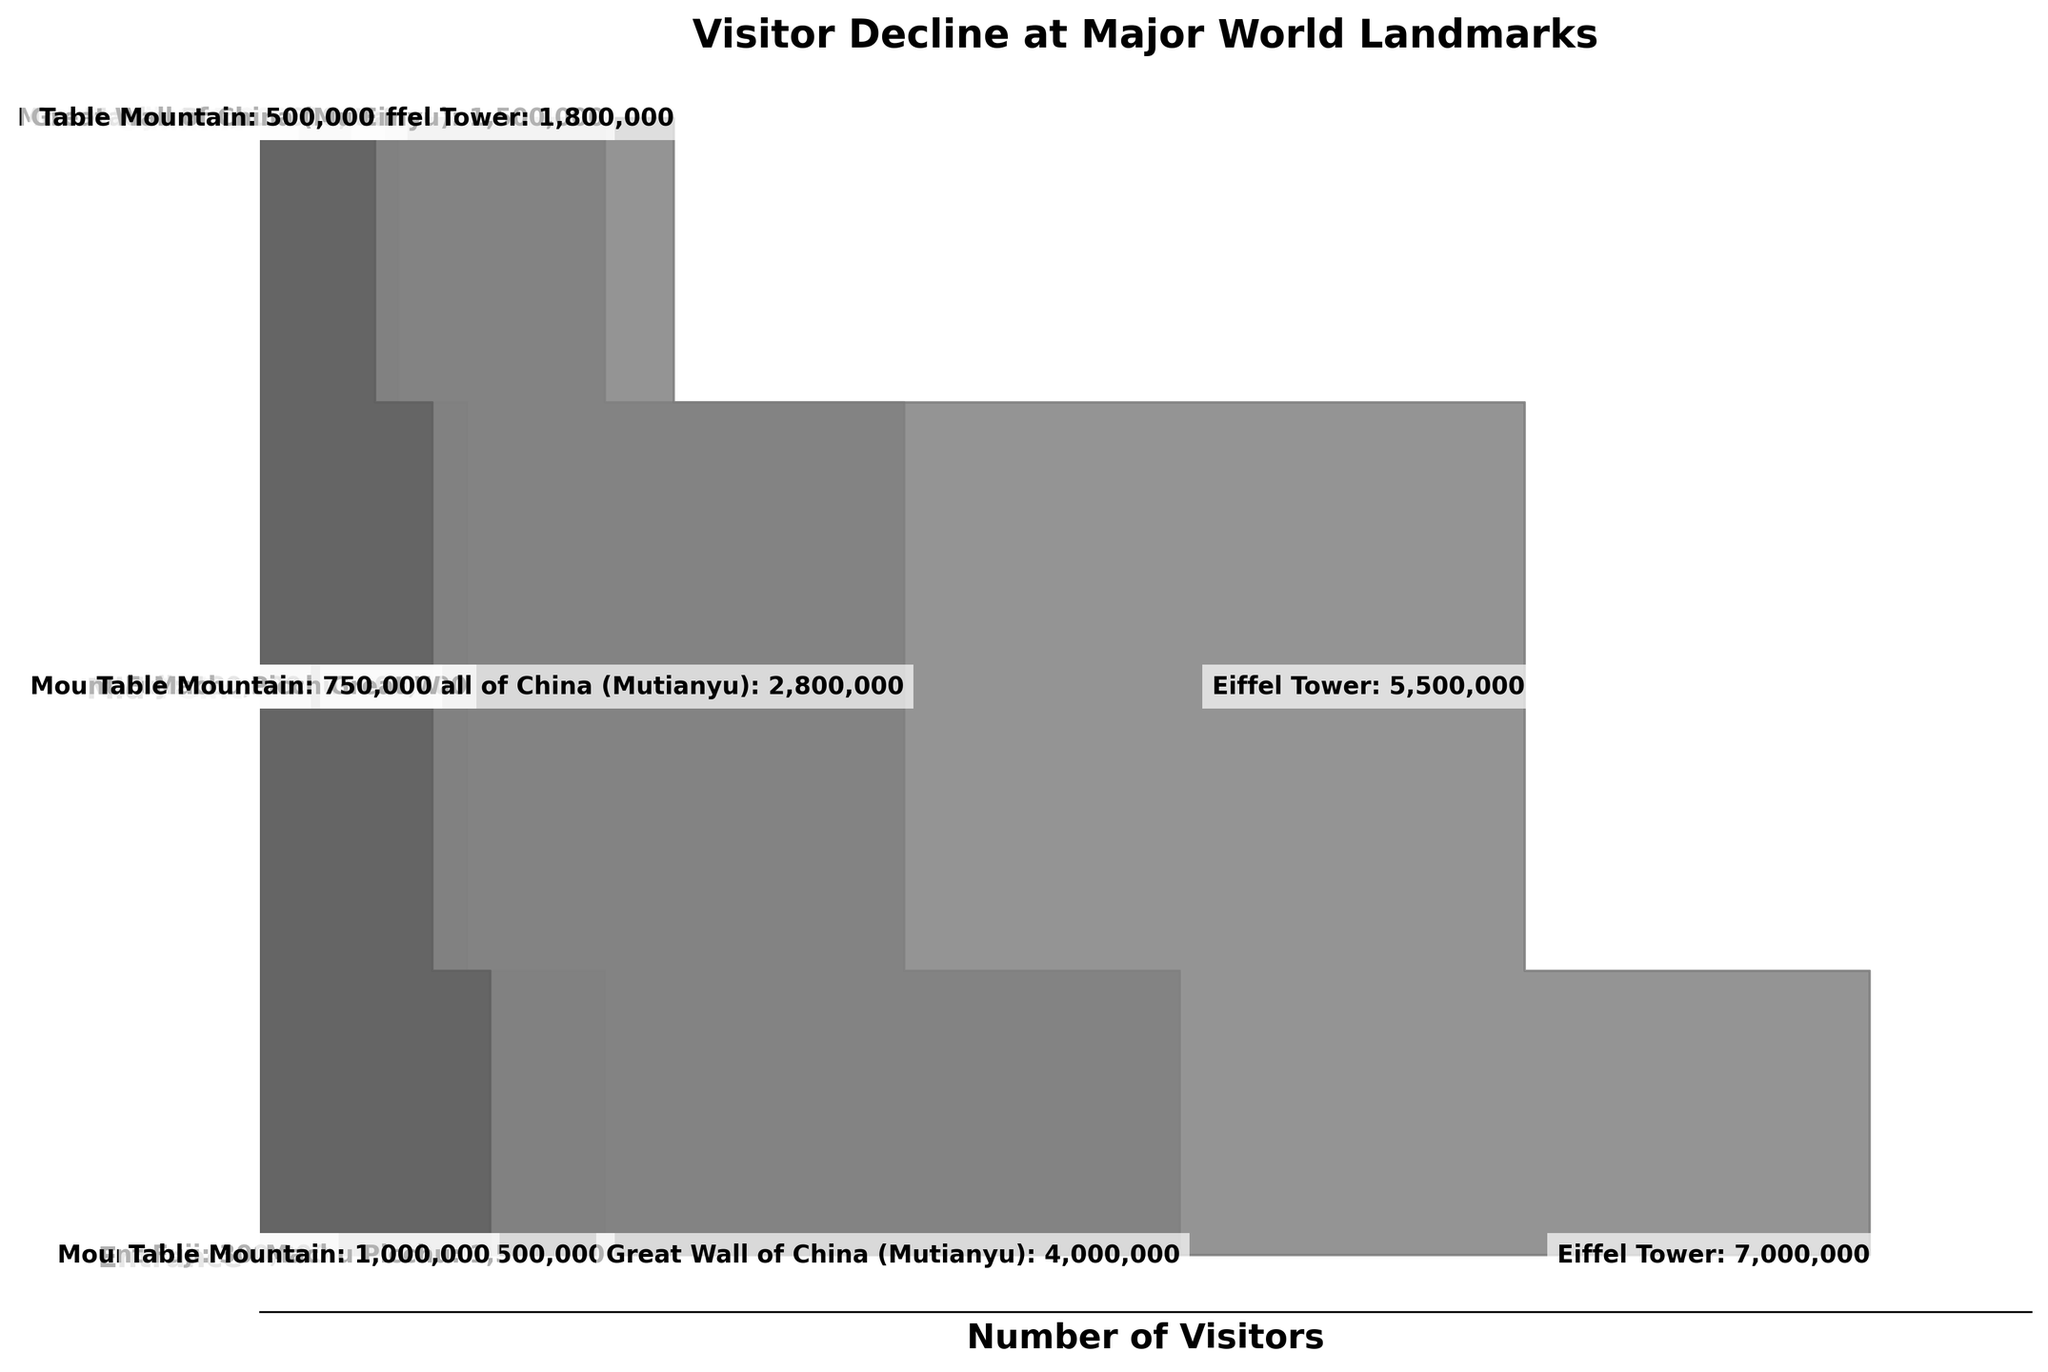What's the landmark with the highest number of visitors at the entrance? The plot shows the number of visitors at different points for each landmark. The landmark with the tallest bar at the 'Entrance' stage is the Eiffel Tower.
Answer: Eiffel Tower Which stage has the greatest decline in visitors for Mount Fuji? For Mount Fuji, compare the heights of the bars for each stage. The decline from 'Entrance' (300,000) to 'Mid-Point' (180,000) is 120,000, whereas the decline from 'Mid-Point' to 'Summit' is 55,000.
Answer: Entrance to Mid-Point How many visitors decline between the entrance and the summit at Machu Picchu? Subtract the number of visitors at the summit from those at the entrance for Machu Picchu: 1,500,000 - 600,000.
Answer: 900,000 Which landmark has the least number of visitors at the summit? The landmark with the shortest bar at the 'Summit' stage is Mount Fuji.
Answer: Mount Fuji Which landmark has the highest visitor retention from the entrance to the summit? Calculate the retention ratio by dividing the number of visitors at the summit by the number at the entrance for each landmark: Mount Fuji (125,000/300,000), Machu Picchu (600,000/1,500,000), Great Wall (1,500,000/4,000,000), Eiffel Tower (1,800,000/7,000,000), Table Mountain (500,000/1,000,000). The highest ratio is for Table Mountain (0.5).
Answer: Table Mountain Which landmark has the greatest absolute decline in visitor numbers from entrance to summit? Compute the absolute difference for each landmark: Mount Fuji (300,000 - 125,000), Machu Picchu (1,500,000 - 600,000), Great Wall (4,000,000 - 1,500,000), Eiffel Tower (7,000,000 - 1,800,000), Table Mountain (1,000,000 - 500,000). The largest decline is for the Eiffel Tower: 5,200,000.
Answer: Eiffel Tower What is the average number of visitors at the 'Mid-Point' for all landmarks? Add the numbers at the 'Mid-Point' for all landmarks and divide by the number of landmarks: (180,000 + 900,000 + 2,800,000 + 5,500,000 + 750,000) / 5.
Answer: 2,026,000 Which two landmarks show the largest relative difference in visitor numbers at the 'Entrance'? Find the ratio of visitors at the 'Entrance' for each pair of landmarks and identify the largest difference. The relevant pairs would indicate the Eiffel Tower and Mount Fuji, with respective visitor numbers of 7,000,000 and 300,000 providing a significant contrast.
Answer: Eiffel Tower and Mount Fuji What's the total number of visitors at the entrance across all landmarks? Sum the visitor numbers at the entrance for all landmarks: 300,000 + 1,500,000 + 4,000,000 + 7,000,000 + 1,000,000.
Answer: 13,800,000 